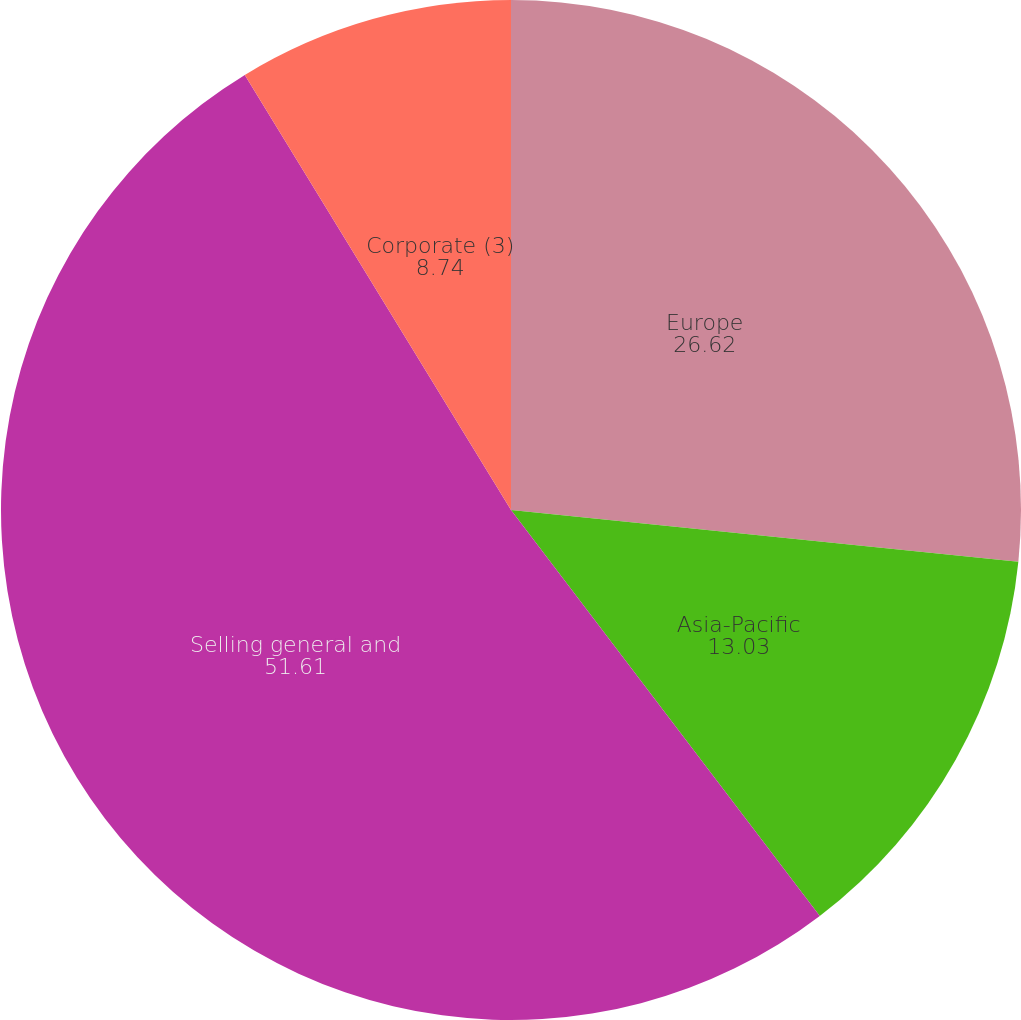<chart> <loc_0><loc_0><loc_500><loc_500><pie_chart><fcel>Europe<fcel>Asia-Pacific<fcel>Selling general and<fcel>Corporate (3)<nl><fcel>26.62%<fcel>13.03%<fcel>51.61%<fcel>8.74%<nl></chart> 